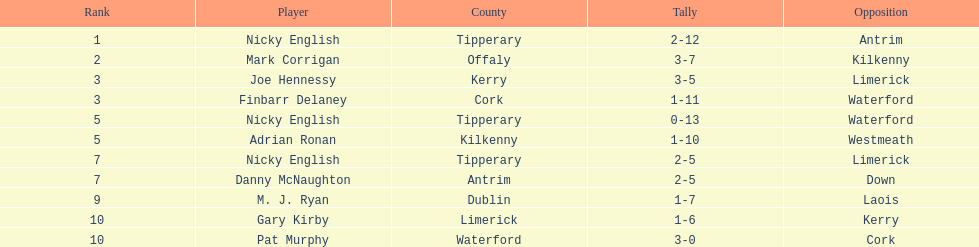Which player ranked the most? Nicky English. 